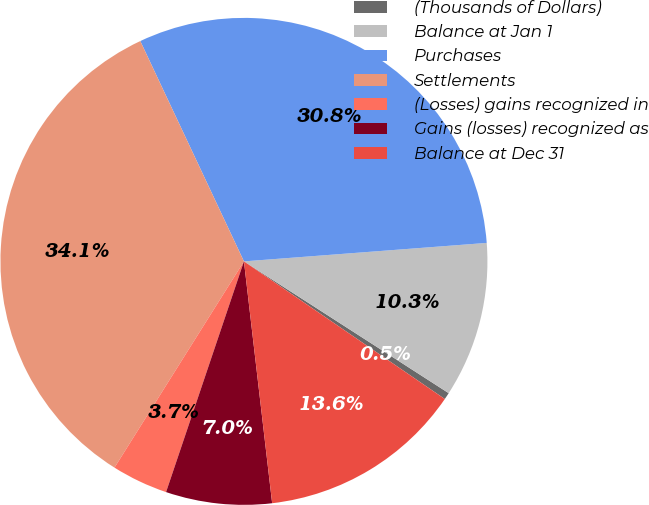Convert chart. <chart><loc_0><loc_0><loc_500><loc_500><pie_chart><fcel>(Thousands of Dollars)<fcel>Balance at Jan 1<fcel>Purchases<fcel>Settlements<fcel>(Losses) gains recognized in<fcel>Gains (losses) recognized as<fcel>Balance at Dec 31<nl><fcel>0.46%<fcel>10.31%<fcel>30.79%<fcel>34.08%<fcel>3.74%<fcel>7.03%<fcel>13.59%<nl></chart> 